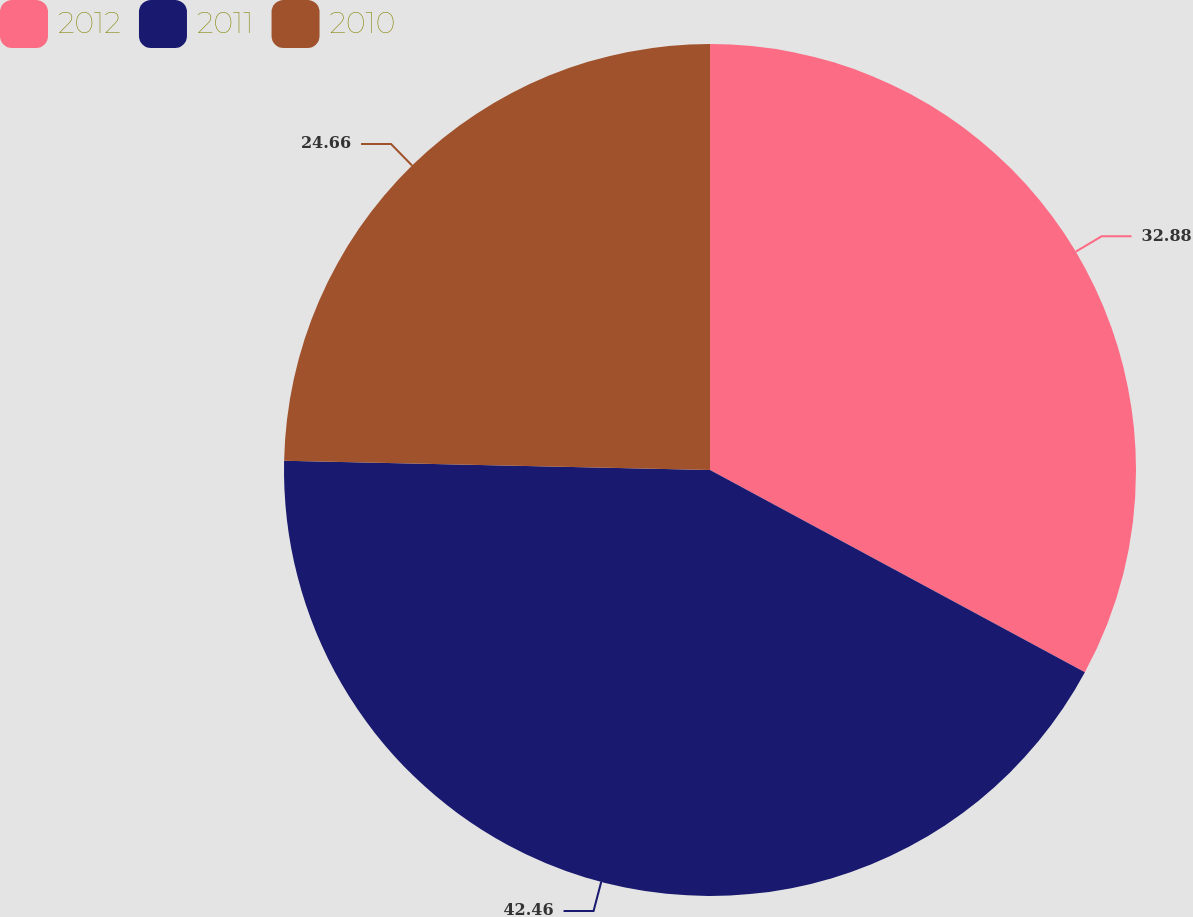<chart> <loc_0><loc_0><loc_500><loc_500><pie_chart><fcel>2012<fcel>2011<fcel>2010<nl><fcel>32.88%<fcel>42.47%<fcel>24.66%<nl></chart> 